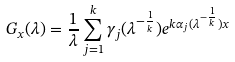<formula> <loc_0><loc_0><loc_500><loc_500>G _ { x } ( \lambda ) = \frac { 1 } { \lambda } \sum ^ { k } _ { j = 1 } \gamma _ { j } ( \lambda ^ { - \frac { 1 } { k } } ) e ^ { k \alpha _ { j } ( \lambda ^ { - \frac { 1 } { k } } ) x }</formula> 